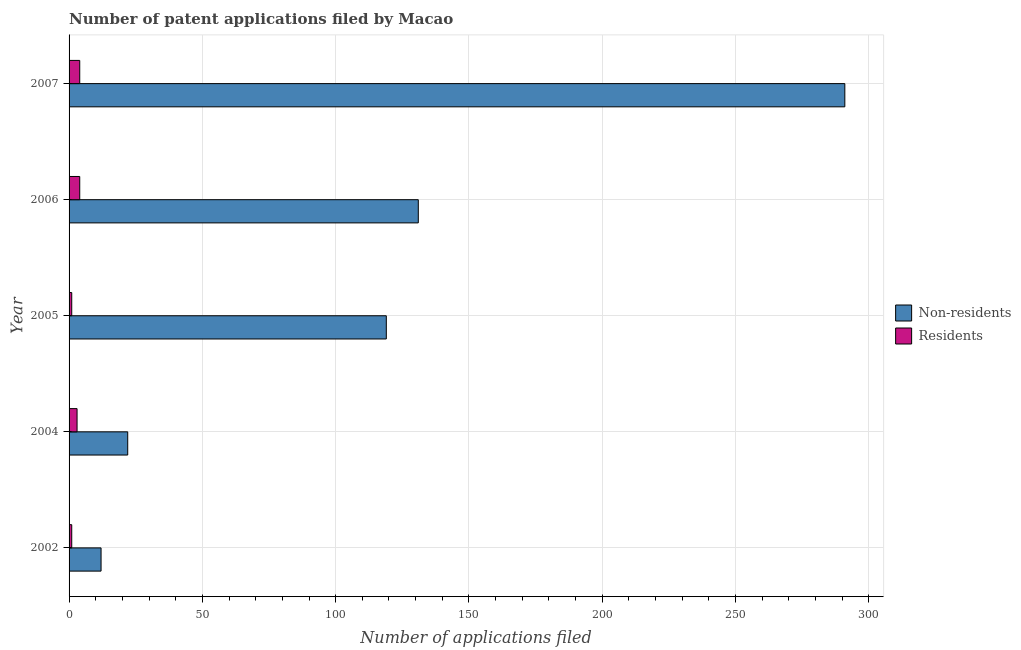How many different coloured bars are there?
Provide a short and direct response. 2. How many bars are there on the 5th tick from the bottom?
Offer a terse response. 2. In how many cases, is the number of bars for a given year not equal to the number of legend labels?
Your answer should be very brief. 0. What is the number of patent applications by non residents in 2002?
Your answer should be very brief. 12. Across all years, what is the maximum number of patent applications by residents?
Provide a short and direct response. 4. Across all years, what is the minimum number of patent applications by non residents?
Your response must be concise. 12. In which year was the number of patent applications by non residents minimum?
Your answer should be compact. 2002. What is the total number of patent applications by non residents in the graph?
Make the answer very short. 575. What is the difference between the number of patent applications by non residents in 2006 and that in 2007?
Keep it short and to the point. -160. What is the difference between the number of patent applications by non residents in 2004 and the number of patent applications by residents in 2002?
Your response must be concise. 21. What is the average number of patent applications by residents per year?
Your answer should be compact. 2.6. In the year 2005, what is the difference between the number of patent applications by residents and number of patent applications by non residents?
Provide a succinct answer. -118. Is the difference between the number of patent applications by non residents in 2005 and 2007 greater than the difference between the number of patent applications by residents in 2005 and 2007?
Keep it short and to the point. No. What is the difference between the highest and the second highest number of patent applications by residents?
Give a very brief answer. 0. What is the difference between the highest and the lowest number of patent applications by residents?
Ensure brevity in your answer.  3. In how many years, is the number of patent applications by non residents greater than the average number of patent applications by non residents taken over all years?
Offer a very short reply. 3. What does the 2nd bar from the top in 2007 represents?
Provide a succinct answer. Non-residents. What does the 1st bar from the bottom in 2007 represents?
Your response must be concise. Non-residents. How many bars are there?
Give a very brief answer. 10. What is the difference between two consecutive major ticks on the X-axis?
Ensure brevity in your answer.  50. Does the graph contain any zero values?
Provide a succinct answer. No. Does the graph contain grids?
Your response must be concise. Yes. How many legend labels are there?
Keep it short and to the point. 2. How are the legend labels stacked?
Offer a terse response. Vertical. What is the title of the graph?
Provide a succinct answer. Number of patent applications filed by Macao. What is the label or title of the X-axis?
Provide a succinct answer. Number of applications filed. What is the label or title of the Y-axis?
Your response must be concise. Year. What is the Number of applications filed of Residents in 2002?
Your answer should be very brief. 1. What is the Number of applications filed of Non-residents in 2004?
Give a very brief answer. 22. What is the Number of applications filed of Non-residents in 2005?
Provide a short and direct response. 119. What is the Number of applications filed of Non-residents in 2006?
Give a very brief answer. 131. What is the Number of applications filed of Non-residents in 2007?
Ensure brevity in your answer.  291. Across all years, what is the maximum Number of applications filed in Non-residents?
Provide a short and direct response. 291. Across all years, what is the maximum Number of applications filed of Residents?
Your answer should be very brief. 4. Across all years, what is the minimum Number of applications filed of Non-residents?
Keep it short and to the point. 12. Across all years, what is the minimum Number of applications filed of Residents?
Ensure brevity in your answer.  1. What is the total Number of applications filed of Non-residents in the graph?
Offer a terse response. 575. What is the difference between the Number of applications filed of Non-residents in 2002 and that in 2004?
Your answer should be compact. -10. What is the difference between the Number of applications filed in Non-residents in 2002 and that in 2005?
Offer a very short reply. -107. What is the difference between the Number of applications filed of Non-residents in 2002 and that in 2006?
Your answer should be very brief. -119. What is the difference between the Number of applications filed in Residents in 2002 and that in 2006?
Provide a succinct answer. -3. What is the difference between the Number of applications filed of Non-residents in 2002 and that in 2007?
Make the answer very short. -279. What is the difference between the Number of applications filed in Residents in 2002 and that in 2007?
Your answer should be compact. -3. What is the difference between the Number of applications filed of Non-residents in 2004 and that in 2005?
Your answer should be very brief. -97. What is the difference between the Number of applications filed in Non-residents in 2004 and that in 2006?
Offer a terse response. -109. What is the difference between the Number of applications filed in Residents in 2004 and that in 2006?
Give a very brief answer. -1. What is the difference between the Number of applications filed of Non-residents in 2004 and that in 2007?
Provide a succinct answer. -269. What is the difference between the Number of applications filed of Residents in 2004 and that in 2007?
Your answer should be compact. -1. What is the difference between the Number of applications filed of Non-residents in 2005 and that in 2007?
Your response must be concise. -172. What is the difference between the Number of applications filed of Non-residents in 2006 and that in 2007?
Offer a very short reply. -160. What is the difference between the Number of applications filed of Non-residents in 2005 and the Number of applications filed of Residents in 2006?
Provide a succinct answer. 115. What is the difference between the Number of applications filed of Non-residents in 2005 and the Number of applications filed of Residents in 2007?
Keep it short and to the point. 115. What is the difference between the Number of applications filed of Non-residents in 2006 and the Number of applications filed of Residents in 2007?
Give a very brief answer. 127. What is the average Number of applications filed in Non-residents per year?
Provide a succinct answer. 115. What is the average Number of applications filed in Residents per year?
Provide a short and direct response. 2.6. In the year 2004, what is the difference between the Number of applications filed of Non-residents and Number of applications filed of Residents?
Your answer should be very brief. 19. In the year 2005, what is the difference between the Number of applications filed in Non-residents and Number of applications filed in Residents?
Ensure brevity in your answer.  118. In the year 2006, what is the difference between the Number of applications filed of Non-residents and Number of applications filed of Residents?
Offer a very short reply. 127. In the year 2007, what is the difference between the Number of applications filed of Non-residents and Number of applications filed of Residents?
Offer a very short reply. 287. What is the ratio of the Number of applications filed of Non-residents in 2002 to that in 2004?
Your response must be concise. 0.55. What is the ratio of the Number of applications filed in Non-residents in 2002 to that in 2005?
Your response must be concise. 0.1. What is the ratio of the Number of applications filed of Residents in 2002 to that in 2005?
Make the answer very short. 1. What is the ratio of the Number of applications filed of Non-residents in 2002 to that in 2006?
Provide a short and direct response. 0.09. What is the ratio of the Number of applications filed of Residents in 2002 to that in 2006?
Offer a very short reply. 0.25. What is the ratio of the Number of applications filed in Non-residents in 2002 to that in 2007?
Your answer should be very brief. 0.04. What is the ratio of the Number of applications filed of Non-residents in 2004 to that in 2005?
Offer a terse response. 0.18. What is the ratio of the Number of applications filed of Non-residents in 2004 to that in 2006?
Offer a terse response. 0.17. What is the ratio of the Number of applications filed of Residents in 2004 to that in 2006?
Offer a terse response. 0.75. What is the ratio of the Number of applications filed in Non-residents in 2004 to that in 2007?
Your response must be concise. 0.08. What is the ratio of the Number of applications filed in Residents in 2004 to that in 2007?
Make the answer very short. 0.75. What is the ratio of the Number of applications filed of Non-residents in 2005 to that in 2006?
Your answer should be very brief. 0.91. What is the ratio of the Number of applications filed in Residents in 2005 to that in 2006?
Ensure brevity in your answer.  0.25. What is the ratio of the Number of applications filed of Non-residents in 2005 to that in 2007?
Ensure brevity in your answer.  0.41. What is the ratio of the Number of applications filed of Non-residents in 2006 to that in 2007?
Your response must be concise. 0.45. What is the ratio of the Number of applications filed in Residents in 2006 to that in 2007?
Offer a very short reply. 1. What is the difference between the highest and the second highest Number of applications filed of Non-residents?
Provide a succinct answer. 160. What is the difference between the highest and the second highest Number of applications filed in Residents?
Provide a short and direct response. 0. What is the difference between the highest and the lowest Number of applications filed in Non-residents?
Offer a very short reply. 279. What is the difference between the highest and the lowest Number of applications filed of Residents?
Your answer should be compact. 3. 